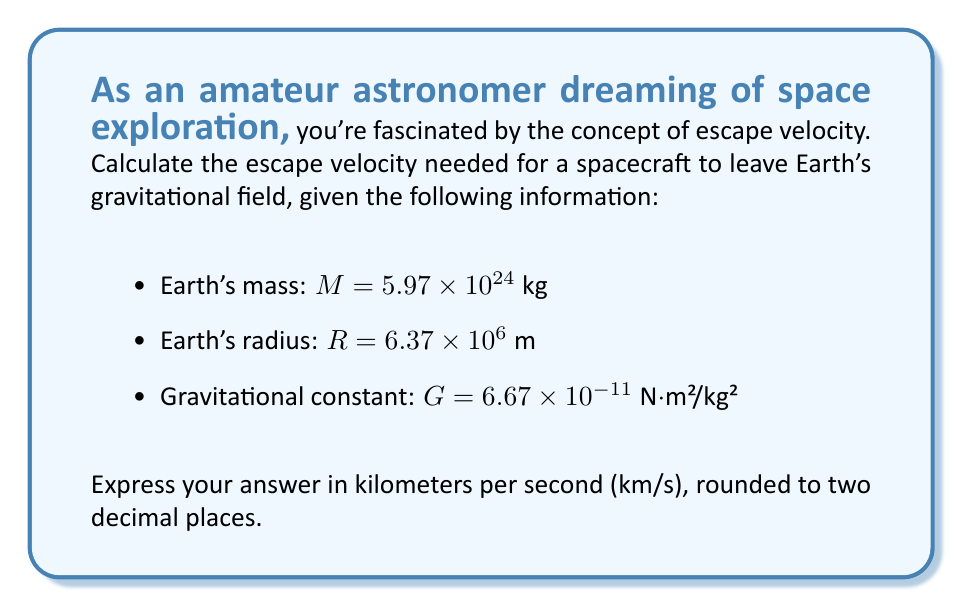Give your solution to this math problem. To calculate the escape velocity, we'll use the escape velocity formula:

$$v_e = \sqrt{\frac{2GM}{R}}$$

Where:
$v_e$ is the escape velocity
$G$ is the gravitational constant
$M$ is the mass of the Earth
$R$ is the radius of the Earth

Let's substitute the given values into the formula:

$$v_e = \sqrt{\frac{2 \cdot (6.67 \times 10^{-11}) \cdot (5.97 \times 10^{24})}{6.37 \times 10^6}}$$

Simplifying inside the square root:

$$v_e = \sqrt{\frac{7.97 \times 10^{14}}{6.37 \times 10^6}}$$

$$v_e = \sqrt{1.25 \times 10^8}$$

$$v_e = 11,184.54 \text{ m/s}$$

To convert this to km/s, we divide by 1000:

$$v_e = 11.18454 \text{ km/s}$$

Rounding to two decimal places:

$$v_e \approx 11.18 \text{ km/s}$$
Answer: 11.18 km/s 